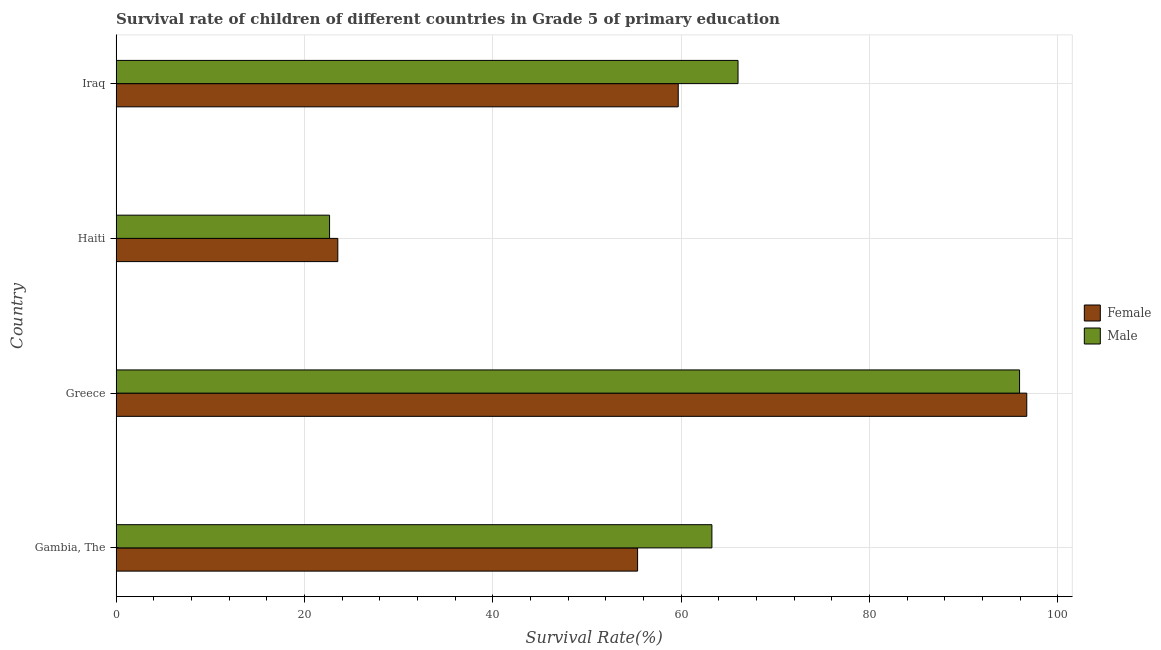Are the number of bars per tick equal to the number of legend labels?
Offer a very short reply. Yes. How many bars are there on the 3rd tick from the top?
Provide a short and direct response. 2. What is the label of the 4th group of bars from the top?
Offer a terse response. Gambia, The. What is the survival rate of male students in primary education in Greece?
Your response must be concise. 95.93. Across all countries, what is the maximum survival rate of female students in primary education?
Make the answer very short. 96.7. Across all countries, what is the minimum survival rate of male students in primary education?
Ensure brevity in your answer.  22.66. In which country was the survival rate of male students in primary education minimum?
Provide a short and direct response. Haiti. What is the total survival rate of female students in primary education in the graph?
Offer a terse response. 235.3. What is the difference between the survival rate of female students in primary education in Gambia, The and that in Haiti?
Offer a very short reply. 31.83. What is the difference between the survival rate of male students in primary education in Gambia, The and the survival rate of female students in primary education in Iraq?
Offer a very short reply. 3.58. What is the average survival rate of female students in primary education per country?
Your answer should be very brief. 58.83. What is the difference between the survival rate of male students in primary education and survival rate of female students in primary education in Gambia, The?
Make the answer very short. 7.89. What is the ratio of the survival rate of male students in primary education in Gambia, The to that in Haiti?
Your response must be concise. 2.79. Is the survival rate of male students in primary education in Gambia, The less than that in Iraq?
Your response must be concise. Yes. Is the difference between the survival rate of male students in primary education in Greece and Haiti greater than the difference between the survival rate of female students in primary education in Greece and Haiti?
Offer a terse response. Yes. What is the difference between the highest and the second highest survival rate of female students in primary education?
Provide a short and direct response. 37.01. What is the difference between the highest and the lowest survival rate of male students in primary education?
Your answer should be compact. 73.27. How many countries are there in the graph?
Your response must be concise. 4. How many legend labels are there?
Ensure brevity in your answer.  2. How are the legend labels stacked?
Provide a succinct answer. Vertical. What is the title of the graph?
Make the answer very short. Survival rate of children of different countries in Grade 5 of primary education. What is the label or title of the X-axis?
Ensure brevity in your answer.  Survival Rate(%). What is the label or title of the Y-axis?
Your answer should be compact. Country. What is the Survival Rate(%) in Female in Gambia, The?
Keep it short and to the point. 55.37. What is the Survival Rate(%) in Male in Gambia, The?
Your response must be concise. 63.26. What is the Survival Rate(%) in Female in Greece?
Ensure brevity in your answer.  96.7. What is the Survival Rate(%) in Male in Greece?
Provide a succinct answer. 95.93. What is the Survival Rate(%) of Female in Haiti?
Make the answer very short. 23.54. What is the Survival Rate(%) of Male in Haiti?
Make the answer very short. 22.66. What is the Survival Rate(%) in Female in Iraq?
Offer a terse response. 59.69. What is the Survival Rate(%) of Male in Iraq?
Keep it short and to the point. 66.04. Across all countries, what is the maximum Survival Rate(%) in Female?
Give a very brief answer. 96.7. Across all countries, what is the maximum Survival Rate(%) of Male?
Make the answer very short. 95.93. Across all countries, what is the minimum Survival Rate(%) in Female?
Your answer should be compact. 23.54. Across all countries, what is the minimum Survival Rate(%) of Male?
Offer a very short reply. 22.66. What is the total Survival Rate(%) in Female in the graph?
Offer a terse response. 235.3. What is the total Survival Rate(%) of Male in the graph?
Offer a very short reply. 247.9. What is the difference between the Survival Rate(%) in Female in Gambia, The and that in Greece?
Your answer should be very brief. -41.33. What is the difference between the Survival Rate(%) in Male in Gambia, The and that in Greece?
Ensure brevity in your answer.  -32.67. What is the difference between the Survival Rate(%) in Female in Gambia, The and that in Haiti?
Provide a short and direct response. 31.83. What is the difference between the Survival Rate(%) in Male in Gambia, The and that in Haiti?
Offer a very short reply. 40.6. What is the difference between the Survival Rate(%) in Female in Gambia, The and that in Iraq?
Provide a short and direct response. -4.32. What is the difference between the Survival Rate(%) in Male in Gambia, The and that in Iraq?
Offer a very short reply. -2.77. What is the difference between the Survival Rate(%) of Female in Greece and that in Haiti?
Provide a short and direct response. 73.16. What is the difference between the Survival Rate(%) in Male in Greece and that in Haiti?
Offer a terse response. 73.27. What is the difference between the Survival Rate(%) in Female in Greece and that in Iraq?
Keep it short and to the point. 37.01. What is the difference between the Survival Rate(%) of Male in Greece and that in Iraq?
Your answer should be compact. 29.89. What is the difference between the Survival Rate(%) in Female in Haiti and that in Iraq?
Ensure brevity in your answer.  -36.15. What is the difference between the Survival Rate(%) in Male in Haiti and that in Iraq?
Make the answer very short. -43.37. What is the difference between the Survival Rate(%) in Female in Gambia, The and the Survival Rate(%) in Male in Greece?
Provide a succinct answer. -40.56. What is the difference between the Survival Rate(%) of Female in Gambia, The and the Survival Rate(%) of Male in Haiti?
Provide a succinct answer. 32.71. What is the difference between the Survival Rate(%) of Female in Gambia, The and the Survival Rate(%) of Male in Iraq?
Your response must be concise. -10.66. What is the difference between the Survival Rate(%) in Female in Greece and the Survival Rate(%) in Male in Haiti?
Make the answer very short. 74.03. What is the difference between the Survival Rate(%) in Female in Greece and the Survival Rate(%) in Male in Iraq?
Offer a very short reply. 30.66. What is the difference between the Survival Rate(%) of Female in Haiti and the Survival Rate(%) of Male in Iraq?
Your response must be concise. -42.5. What is the average Survival Rate(%) in Female per country?
Provide a succinct answer. 58.82. What is the average Survival Rate(%) of Male per country?
Your answer should be compact. 61.97. What is the difference between the Survival Rate(%) of Female and Survival Rate(%) of Male in Gambia, The?
Your response must be concise. -7.89. What is the difference between the Survival Rate(%) of Female and Survival Rate(%) of Male in Greece?
Your answer should be compact. 0.77. What is the difference between the Survival Rate(%) in Female and Survival Rate(%) in Male in Haiti?
Offer a very short reply. 0.88. What is the difference between the Survival Rate(%) of Female and Survival Rate(%) of Male in Iraq?
Your response must be concise. -6.35. What is the ratio of the Survival Rate(%) in Female in Gambia, The to that in Greece?
Your answer should be very brief. 0.57. What is the ratio of the Survival Rate(%) of Male in Gambia, The to that in Greece?
Your answer should be very brief. 0.66. What is the ratio of the Survival Rate(%) in Female in Gambia, The to that in Haiti?
Provide a succinct answer. 2.35. What is the ratio of the Survival Rate(%) of Male in Gambia, The to that in Haiti?
Keep it short and to the point. 2.79. What is the ratio of the Survival Rate(%) in Female in Gambia, The to that in Iraq?
Make the answer very short. 0.93. What is the ratio of the Survival Rate(%) of Male in Gambia, The to that in Iraq?
Ensure brevity in your answer.  0.96. What is the ratio of the Survival Rate(%) in Female in Greece to that in Haiti?
Offer a very short reply. 4.11. What is the ratio of the Survival Rate(%) in Male in Greece to that in Haiti?
Give a very brief answer. 4.23. What is the ratio of the Survival Rate(%) in Female in Greece to that in Iraq?
Your response must be concise. 1.62. What is the ratio of the Survival Rate(%) in Male in Greece to that in Iraq?
Offer a very short reply. 1.45. What is the ratio of the Survival Rate(%) in Female in Haiti to that in Iraq?
Your answer should be very brief. 0.39. What is the ratio of the Survival Rate(%) in Male in Haiti to that in Iraq?
Keep it short and to the point. 0.34. What is the difference between the highest and the second highest Survival Rate(%) of Female?
Provide a succinct answer. 37.01. What is the difference between the highest and the second highest Survival Rate(%) of Male?
Provide a succinct answer. 29.89. What is the difference between the highest and the lowest Survival Rate(%) in Female?
Make the answer very short. 73.16. What is the difference between the highest and the lowest Survival Rate(%) of Male?
Make the answer very short. 73.27. 